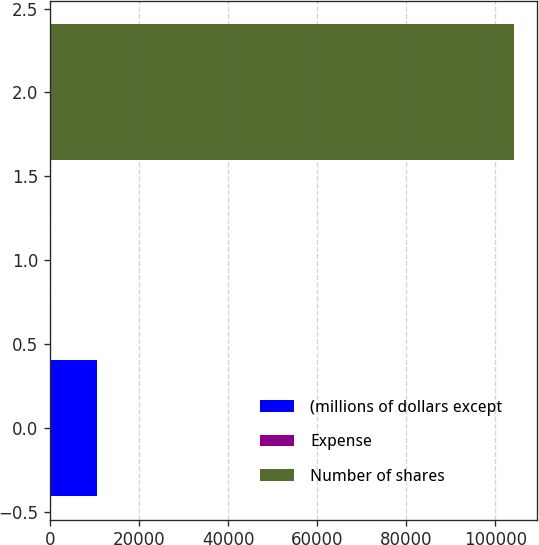<chart> <loc_0><loc_0><loc_500><loc_500><bar_chart><fcel>(millions of dollars except<fcel>Expense<fcel>Number of shares<nl><fcel>10442<fcel>23.9<fcel>104205<nl></chart> 